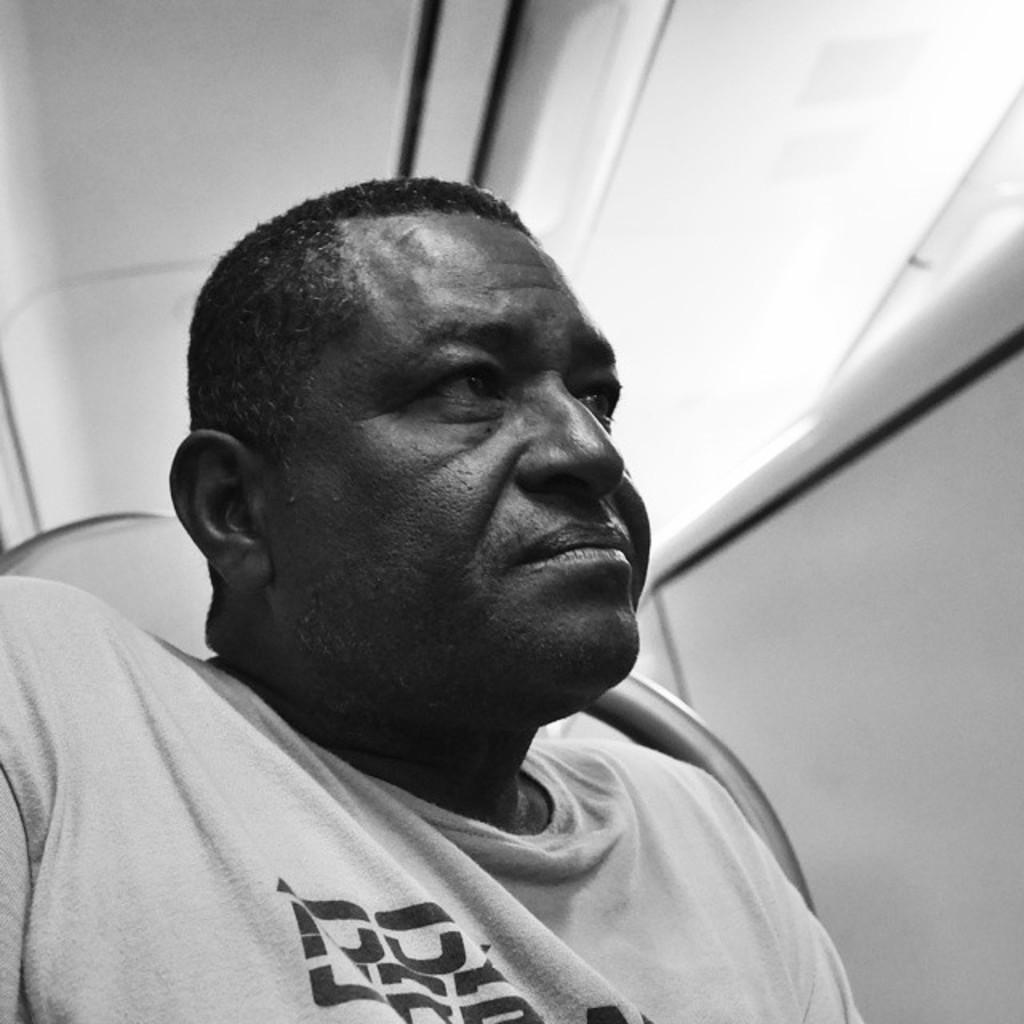Describe this image in one or two sentences. This is a black and white picture, we can see a person sitting on the chair and we can also see the wall and a roof. 